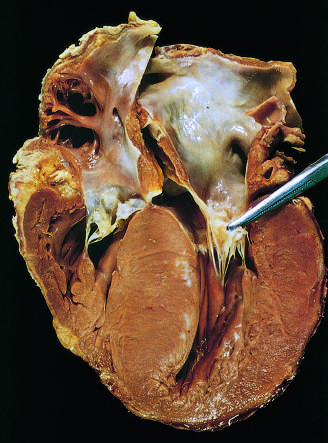s the left atrium enlarged?
Answer the question using a single word or phrase. Yes 